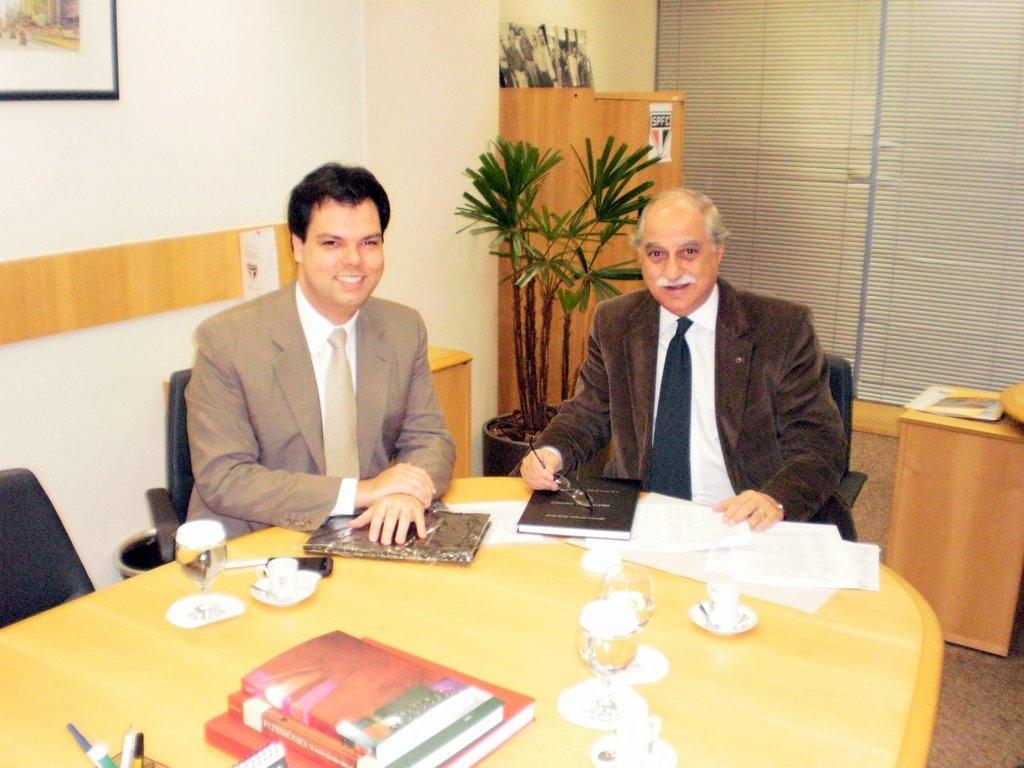How would you summarize this image in a sentence or two? There is a person in a suit smiling, sitting on a chair and placing both hands on a book which is on the table on which, there are cups arranged, there are cuts on the saucers. Beside him, another person who is holding a spectacle and placing hand on the table. In the background, there is a pot plant, there is a photo frame on the wall, there is a cupboard and a curtain. 